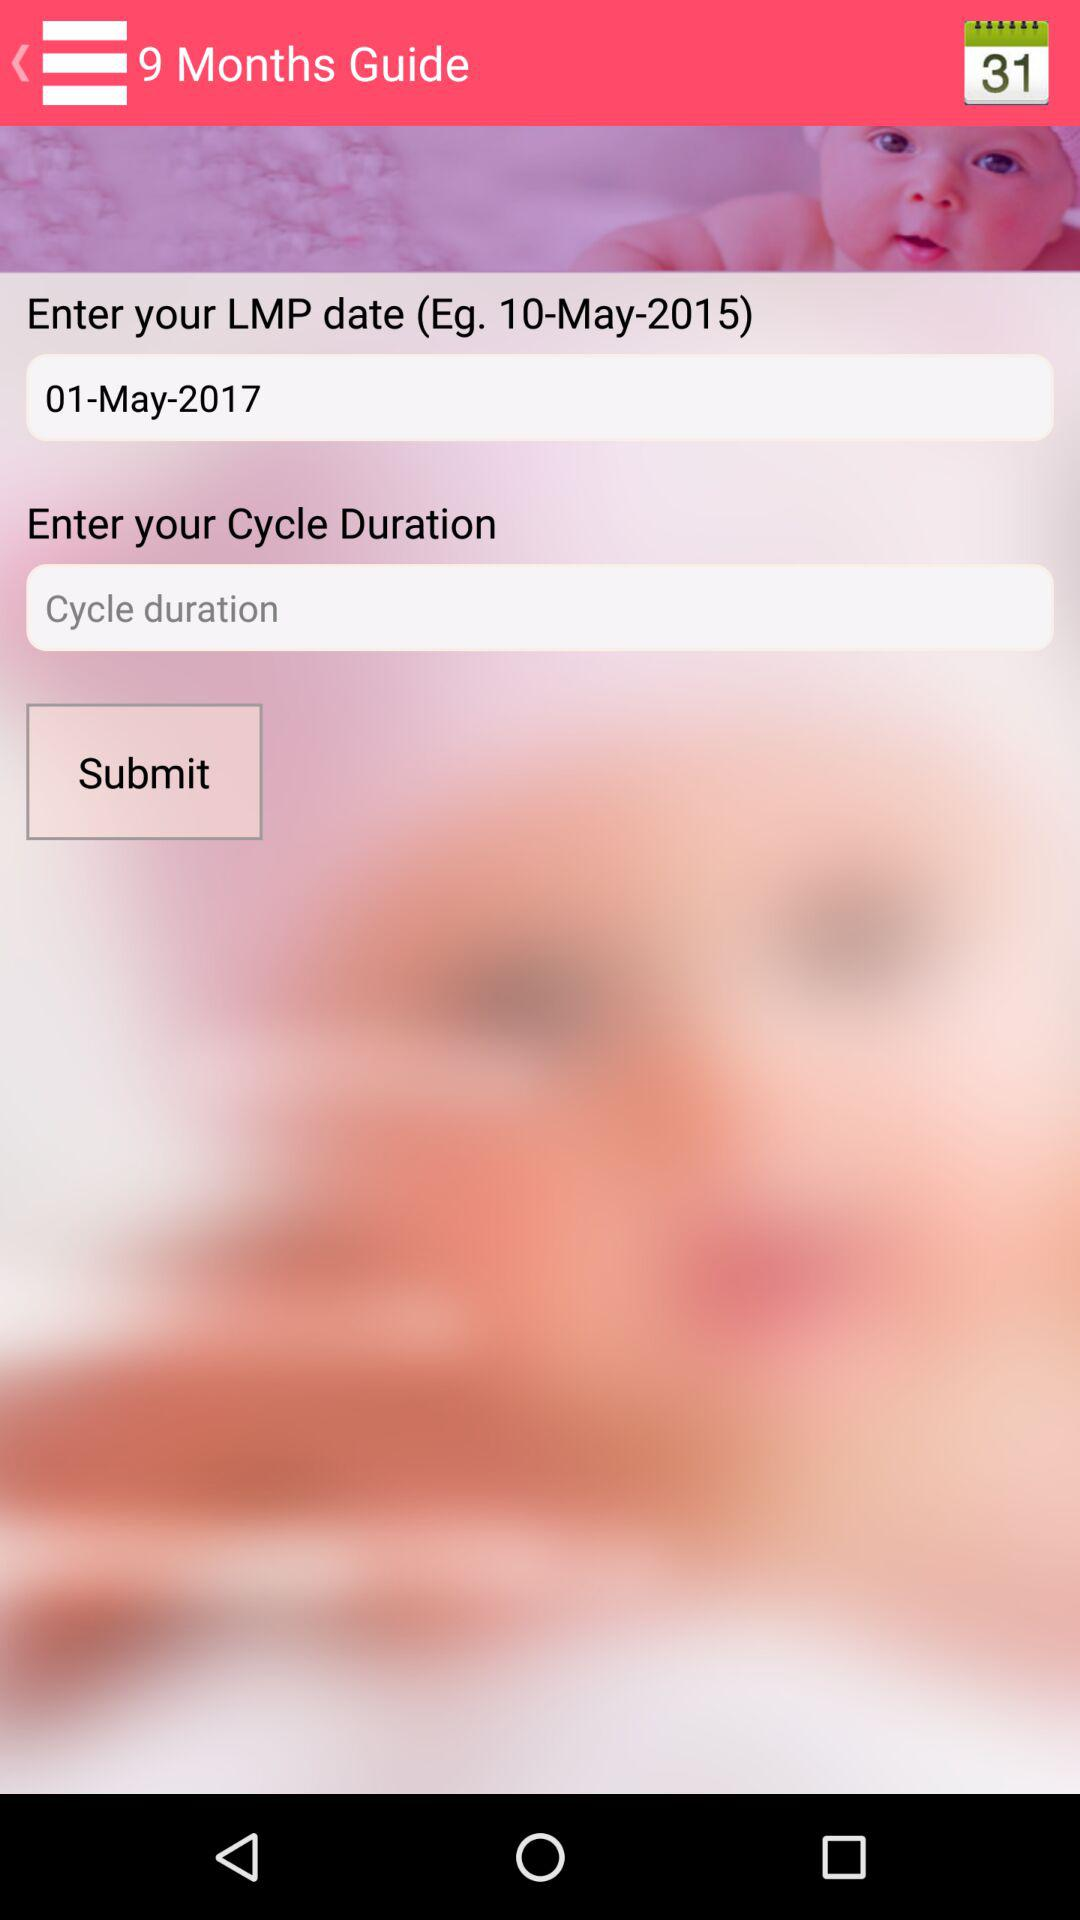What is the LMP date? The LMP date is May 1, 2017. 